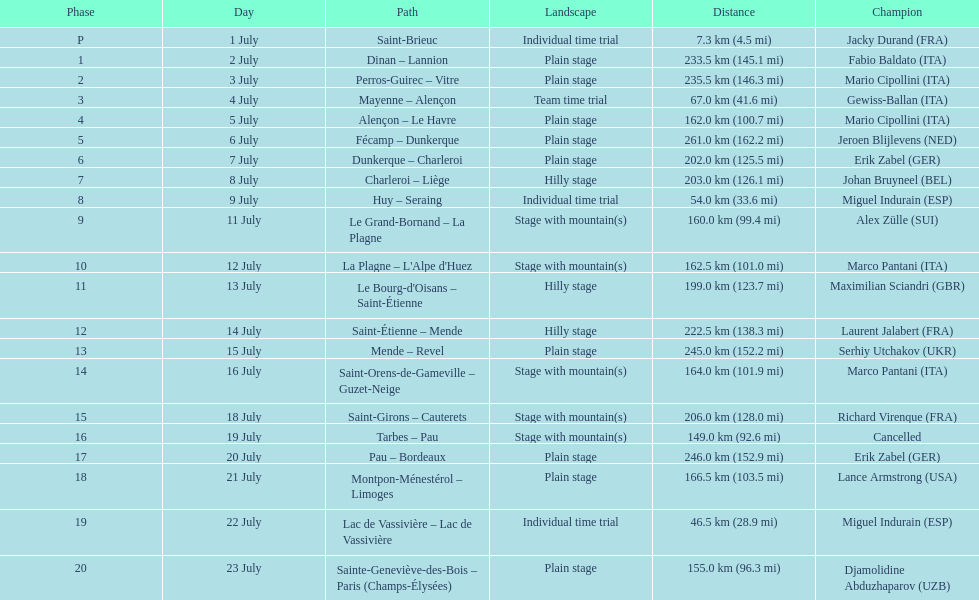How many stages were at least 200 km in length in the 1995 tour de france? 9. Parse the table in full. {'header': ['Phase', 'Day', 'Path', 'Landscape', 'Distance', 'Champion'], 'rows': [['P', '1 July', 'Saint-Brieuc', 'Individual time trial', '7.3\xa0km (4.5\xa0mi)', 'Jacky Durand\xa0(FRA)'], ['1', '2 July', 'Dinan – Lannion', 'Plain stage', '233.5\xa0km (145.1\xa0mi)', 'Fabio Baldato\xa0(ITA)'], ['2', '3 July', 'Perros-Guirec – Vitre', 'Plain stage', '235.5\xa0km (146.3\xa0mi)', 'Mario Cipollini\xa0(ITA)'], ['3', '4 July', 'Mayenne – Alençon', 'Team time trial', '67.0\xa0km (41.6\xa0mi)', 'Gewiss-Ballan\xa0(ITA)'], ['4', '5 July', 'Alençon – Le Havre', 'Plain stage', '162.0\xa0km (100.7\xa0mi)', 'Mario Cipollini\xa0(ITA)'], ['5', '6 July', 'Fécamp – Dunkerque', 'Plain stage', '261.0\xa0km (162.2\xa0mi)', 'Jeroen Blijlevens\xa0(NED)'], ['6', '7 July', 'Dunkerque – Charleroi', 'Plain stage', '202.0\xa0km (125.5\xa0mi)', 'Erik Zabel\xa0(GER)'], ['7', '8 July', 'Charleroi – Liège', 'Hilly stage', '203.0\xa0km (126.1\xa0mi)', 'Johan Bruyneel\xa0(BEL)'], ['8', '9 July', 'Huy – Seraing', 'Individual time trial', '54.0\xa0km (33.6\xa0mi)', 'Miguel Indurain\xa0(ESP)'], ['9', '11 July', 'Le Grand-Bornand – La Plagne', 'Stage with mountain(s)', '160.0\xa0km (99.4\xa0mi)', 'Alex Zülle\xa0(SUI)'], ['10', '12 July', "La Plagne – L'Alpe d'Huez", 'Stage with mountain(s)', '162.5\xa0km (101.0\xa0mi)', 'Marco Pantani\xa0(ITA)'], ['11', '13 July', "Le Bourg-d'Oisans – Saint-Étienne", 'Hilly stage', '199.0\xa0km (123.7\xa0mi)', 'Maximilian Sciandri\xa0(GBR)'], ['12', '14 July', 'Saint-Étienne – Mende', 'Hilly stage', '222.5\xa0km (138.3\xa0mi)', 'Laurent Jalabert\xa0(FRA)'], ['13', '15 July', 'Mende – Revel', 'Plain stage', '245.0\xa0km (152.2\xa0mi)', 'Serhiy Utchakov\xa0(UKR)'], ['14', '16 July', 'Saint-Orens-de-Gameville – Guzet-Neige', 'Stage with mountain(s)', '164.0\xa0km (101.9\xa0mi)', 'Marco Pantani\xa0(ITA)'], ['15', '18 July', 'Saint-Girons – Cauterets', 'Stage with mountain(s)', '206.0\xa0km (128.0\xa0mi)', 'Richard Virenque\xa0(FRA)'], ['16', '19 July', 'Tarbes – Pau', 'Stage with mountain(s)', '149.0\xa0km (92.6\xa0mi)', 'Cancelled'], ['17', '20 July', 'Pau – Bordeaux', 'Plain stage', '246.0\xa0km (152.9\xa0mi)', 'Erik Zabel\xa0(GER)'], ['18', '21 July', 'Montpon-Ménestérol – Limoges', 'Plain stage', '166.5\xa0km (103.5\xa0mi)', 'Lance Armstrong\xa0(USA)'], ['19', '22 July', 'Lac de Vassivière – Lac de Vassivière', 'Individual time trial', '46.5\xa0km (28.9\xa0mi)', 'Miguel Indurain\xa0(ESP)'], ['20', '23 July', 'Sainte-Geneviève-des-Bois – Paris (Champs-Élysées)', 'Plain stage', '155.0\xa0km (96.3\xa0mi)', 'Djamolidine Abduzhaparov\xa0(UZB)']]} 